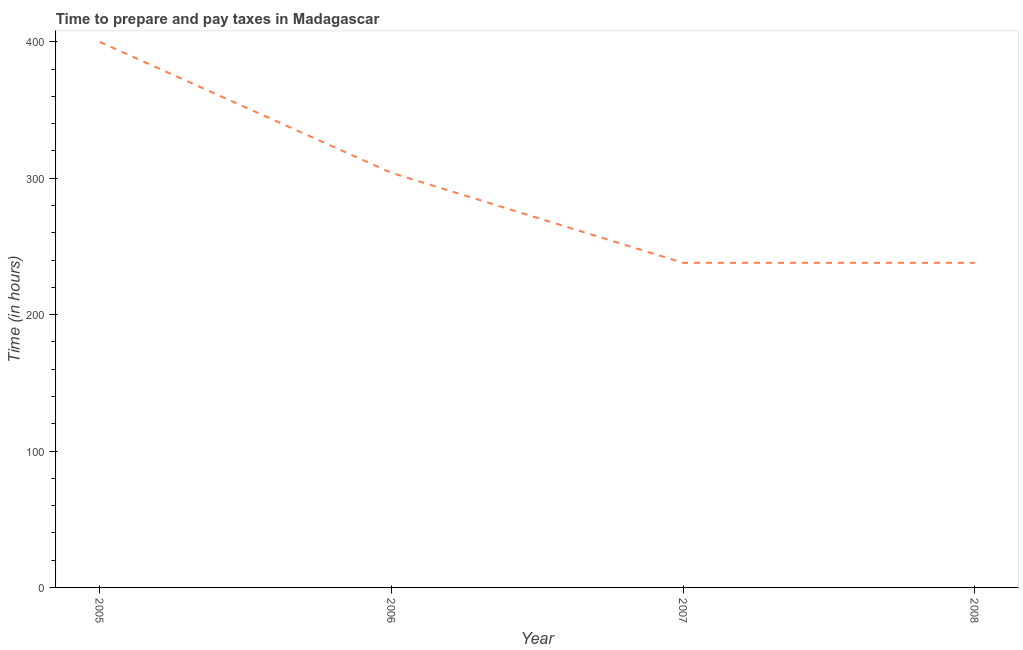What is the time to prepare and pay taxes in 2008?
Ensure brevity in your answer.  238. Across all years, what is the maximum time to prepare and pay taxes?
Make the answer very short. 400. Across all years, what is the minimum time to prepare and pay taxes?
Keep it short and to the point. 238. In which year was the time to prepare and pay taxes maximum?
Provide a succinct answer. 2005. What is the sum of the time to prepare and pay taxes?
Make the answer very short. 1180. What is the difference between the time to prepare and pay taxes in 2005 and 2007?
Ensure brevity in your answer.  162. What is the average time to prepare and pay taxes per year?
Ensure brevity in your answer.  295. What is the median time to prepare and pay taxes?
Make the answer very short. 271. Do a majority of the years between 2007 and 2008 (inclusive) have time to prepare and pay taxes greater than 60 hours?
Provide a succinct answer. Yes. What is the ratio of the time to prepare and pay taxes in 2005 to that in 2008?
Make the answer very short. 1.68. What is the difference between the highest and the second highest time to prepare and pay taxes?
Offer a terse response. 96. What is the difference between the highest and the lowest time to prepare and pay taxes?
Your answer should be very brief. 162. What is the difference between two consecutive major ticks on the Y-axis?
Your response must be concise. 100. Does the graph contain grids?
Keep it short and to the point. No. What is the title of the graph?
Provide a short and direct response. Time to prepare and pay taxes in Madagascar. What is the label or title of the Y-axis?
Your response must be concise. Time (in hours). What is the Time (in hours) of 2005?
Make the answer very short. 400. What is the Time (in hours) of 2006?
Provide a short and direct response. 304. What is the Time (in hours) of 2007?
Give a very brief answer. 238. What is the Time (in hours) in 2008?
Make the answer very short. 238. What is the difference between the Time (in hours) in 2005 and 2006?
Give a very brief answer. 96. What is the difference between the Time (in hours) in 2005 and 2007?
Give a very brief answer. 162. What is the difference between the Time (in hours) in 2005 and 2008?
Your answer should be very brief. 162. What is the difference between the Time (in hours) in 2006 and 2008?
Provide a short and direct response. 66. What is the difference between the Time (in hours) in 2007 and 2008?
Your answer should be very brief. 0. What is the ratio of the Time (in hours) in 2005 to that in 2006?
Make the answer very short. 1.32. What is the ratio of the Time (in hours) in 2005 to that in 2007?
Your answer should be very brief. 1.68. What is the ratio of the Time (in hours) in 2005 to that in 2008?
Keep it short and to the point. 1.68. What is the ratio of the Time (in hours) in 2006 to that in 2007?
Give a very brief answer. 1.28. What is the ratio of the Time (in hours) in 2006 to that in 2008?
Make the answer very short. 1.28. What is the ratio of the Time (in hours) in 2007 to that in 2008?
Your answer should be very brief. 1. 